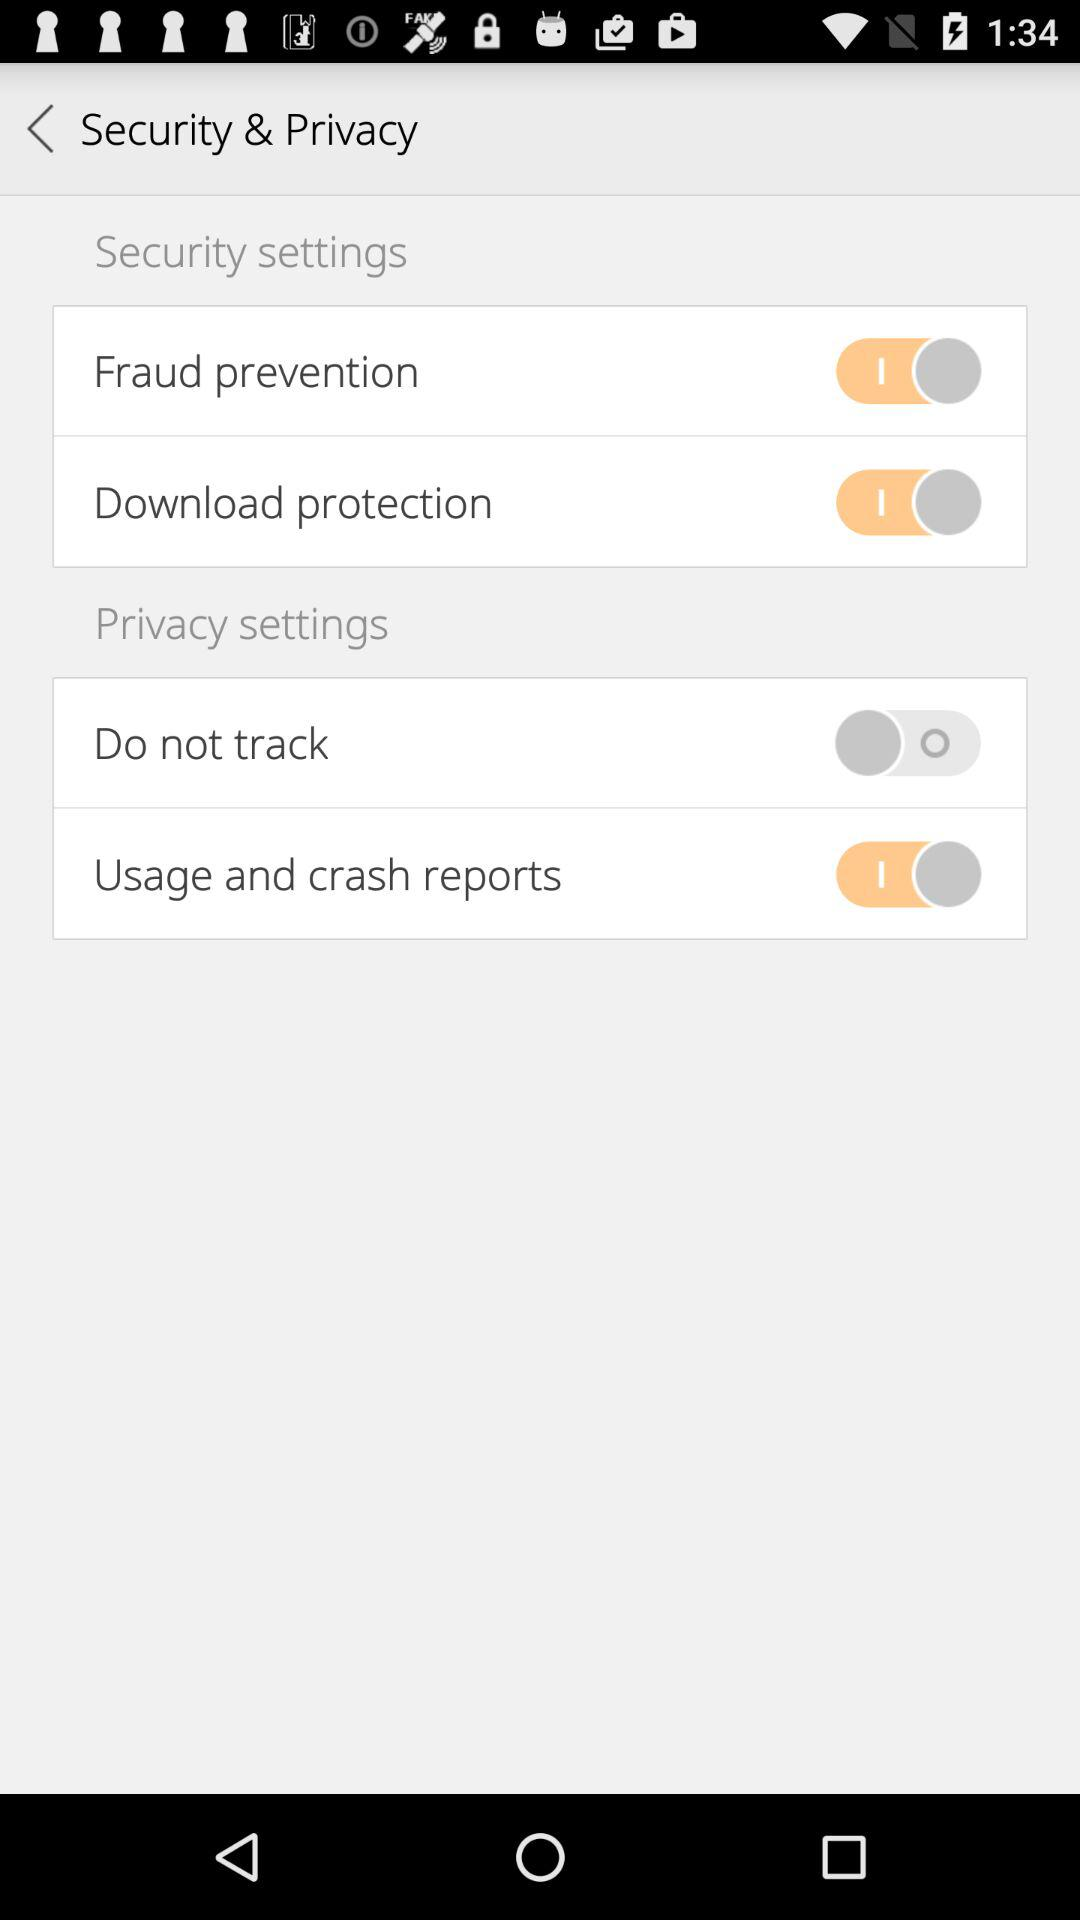What is the status of "Usage and crash reports"? The status is "on". 